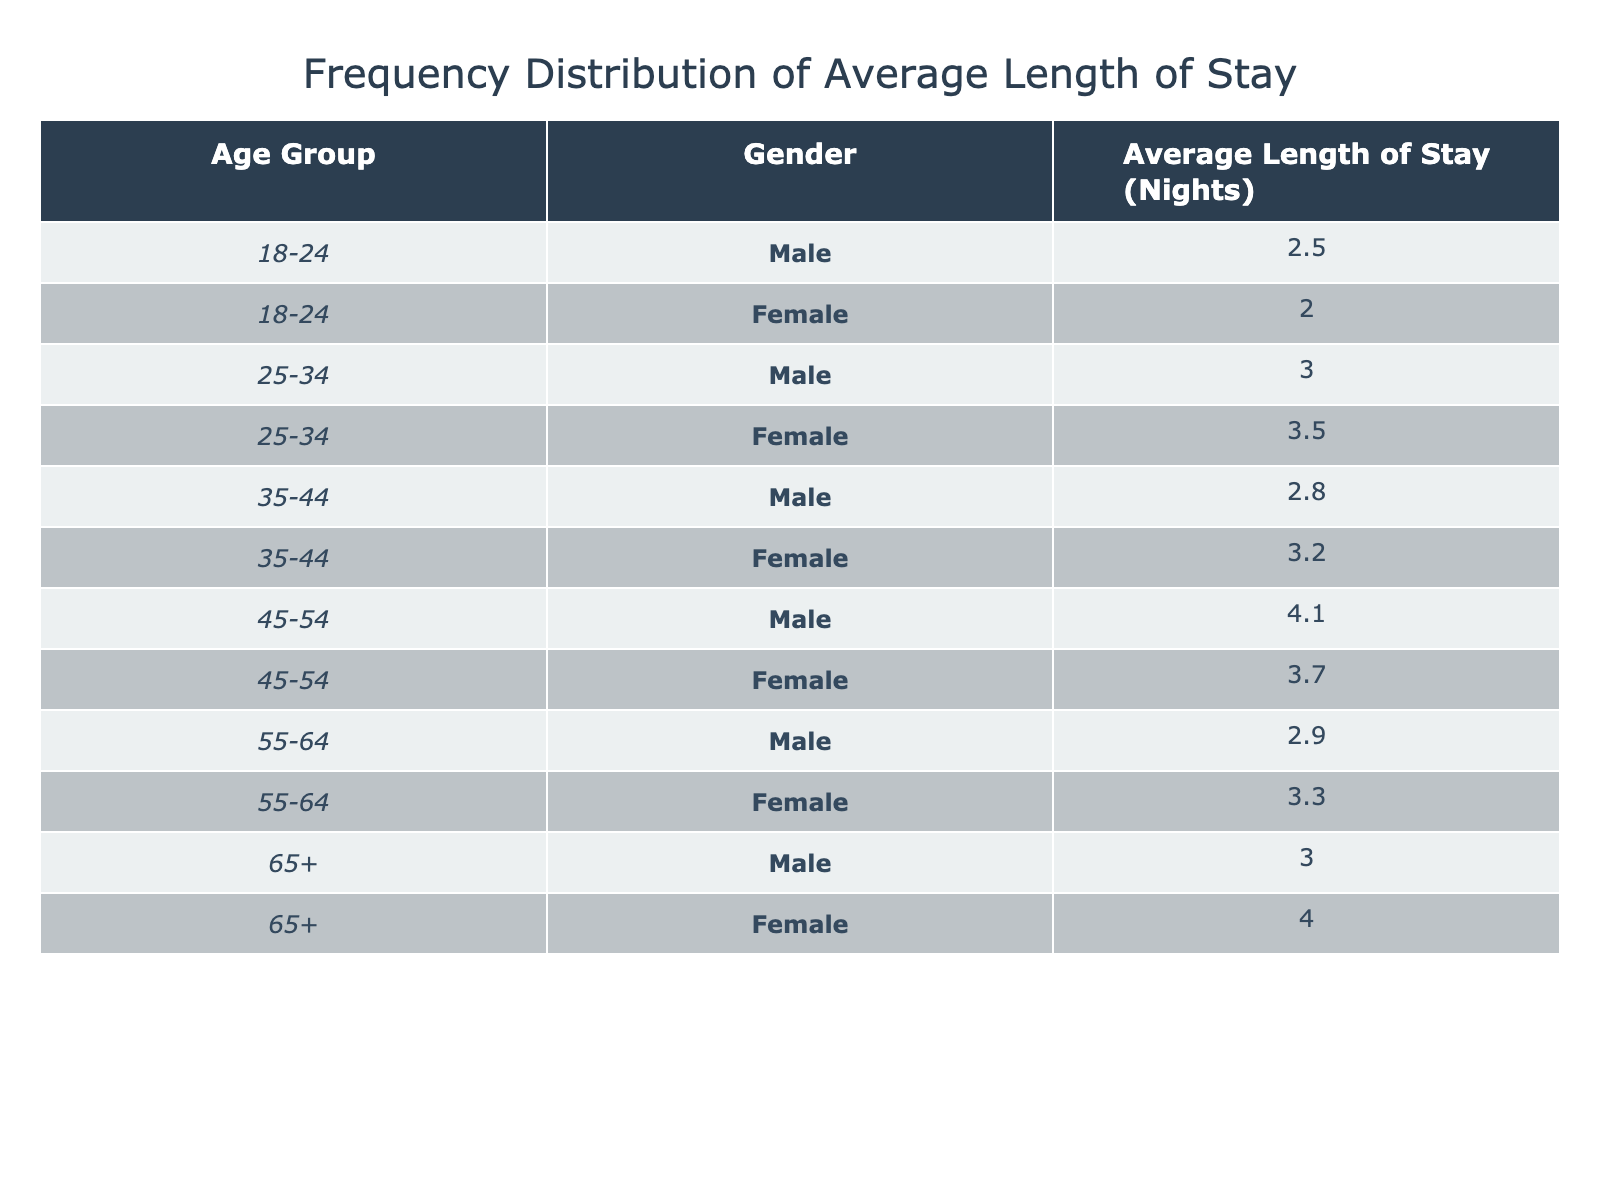What is the average length of stay for female guests in the age group 25-34? The table shows that the average length of stay for female guests in the age group 25-34 is 3.5 nights.
Answer: 3.5 What is the average length of stay for male guests aged 45-54? According to the table, male guests aged 45-54 have an average length of stay of 4.1 nights.
Answer: 4.1 How many total nights do male guests across all age groups stay on average? To find the total, we add up the average lengths for male guests: (2.5 + 3.0 + 2.8 + 4.1 + 2.9 + 3.0) = 18.3 nights. There are 6 male guests, so the average is 18.3 / 6 = 3.05 nights.
Answer: 3.05 Is the average length of stay for guests aged 65 and above greater for females than for males? Looking at the table, the average length of stay for females aged 65+ is 4.0 nights, while for males it is 3.0 nights. Since 4.0 > 3.0, this statement is true.
Answer: Yes What is the difference in average length of stay between male and female guests in the 35-44 age group? The average length of stay for males in this group is 2.8 nights and for females, it is 3.2 nights. The difference is 3.2 - 2.8 = 0.4 nights.
Answer: 0.4 How does the average length of stay for female guests in the 18-24 age group compare to those in the 55-64 age group? From the table, females aged 18-24 have an average stay of 2.0 nights, while those aged 55-64 stay for an average of 3.3 nights. Comparing these, 3.3 > 2.0 indicates that 55-64 year-old females stay longer.
Answer: 55-64 year-old females stay longer Which age group has the highest average length of stay among male guests? The table indicates that the highest average for male guests is from the 45-54 age group at 4.1 nights, which is greater than any other age group listed for males.
Answer: 45-54 What is the average length of stay for all guests (both genders across all age groups)? We sum all average lengths: (2.5 + 2.0 + 3.0 + 3.5 + 2.8 + 3.2 + 4.1 + 3.7 + 2.9 + 3.3 + 3.0 + 4.0) = 34.0 nights. Since there are 12 data points, the average is 34.0 / 12 = 2.83 nights.
Answer: 2.83 Are there more age groups with an average stay of 3 nights or more compared to those below 3 nights? Reviewing the table, the age groups with averages of 3 nights or more are: 25-34, 35-44, 45-54, 55-64, and 65+. There are 5 such groups. The ones below 3 nights are 18-24 for both genders and the 55-64 male, giving us 3 groups. Therefore, there are more age groups with stays of 3 nights or more.
Answer: Yes 